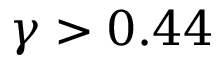<formula> <loc_0><loc_0><loc_500><loc_500>\gamma > 0 . 4 4</formula> 